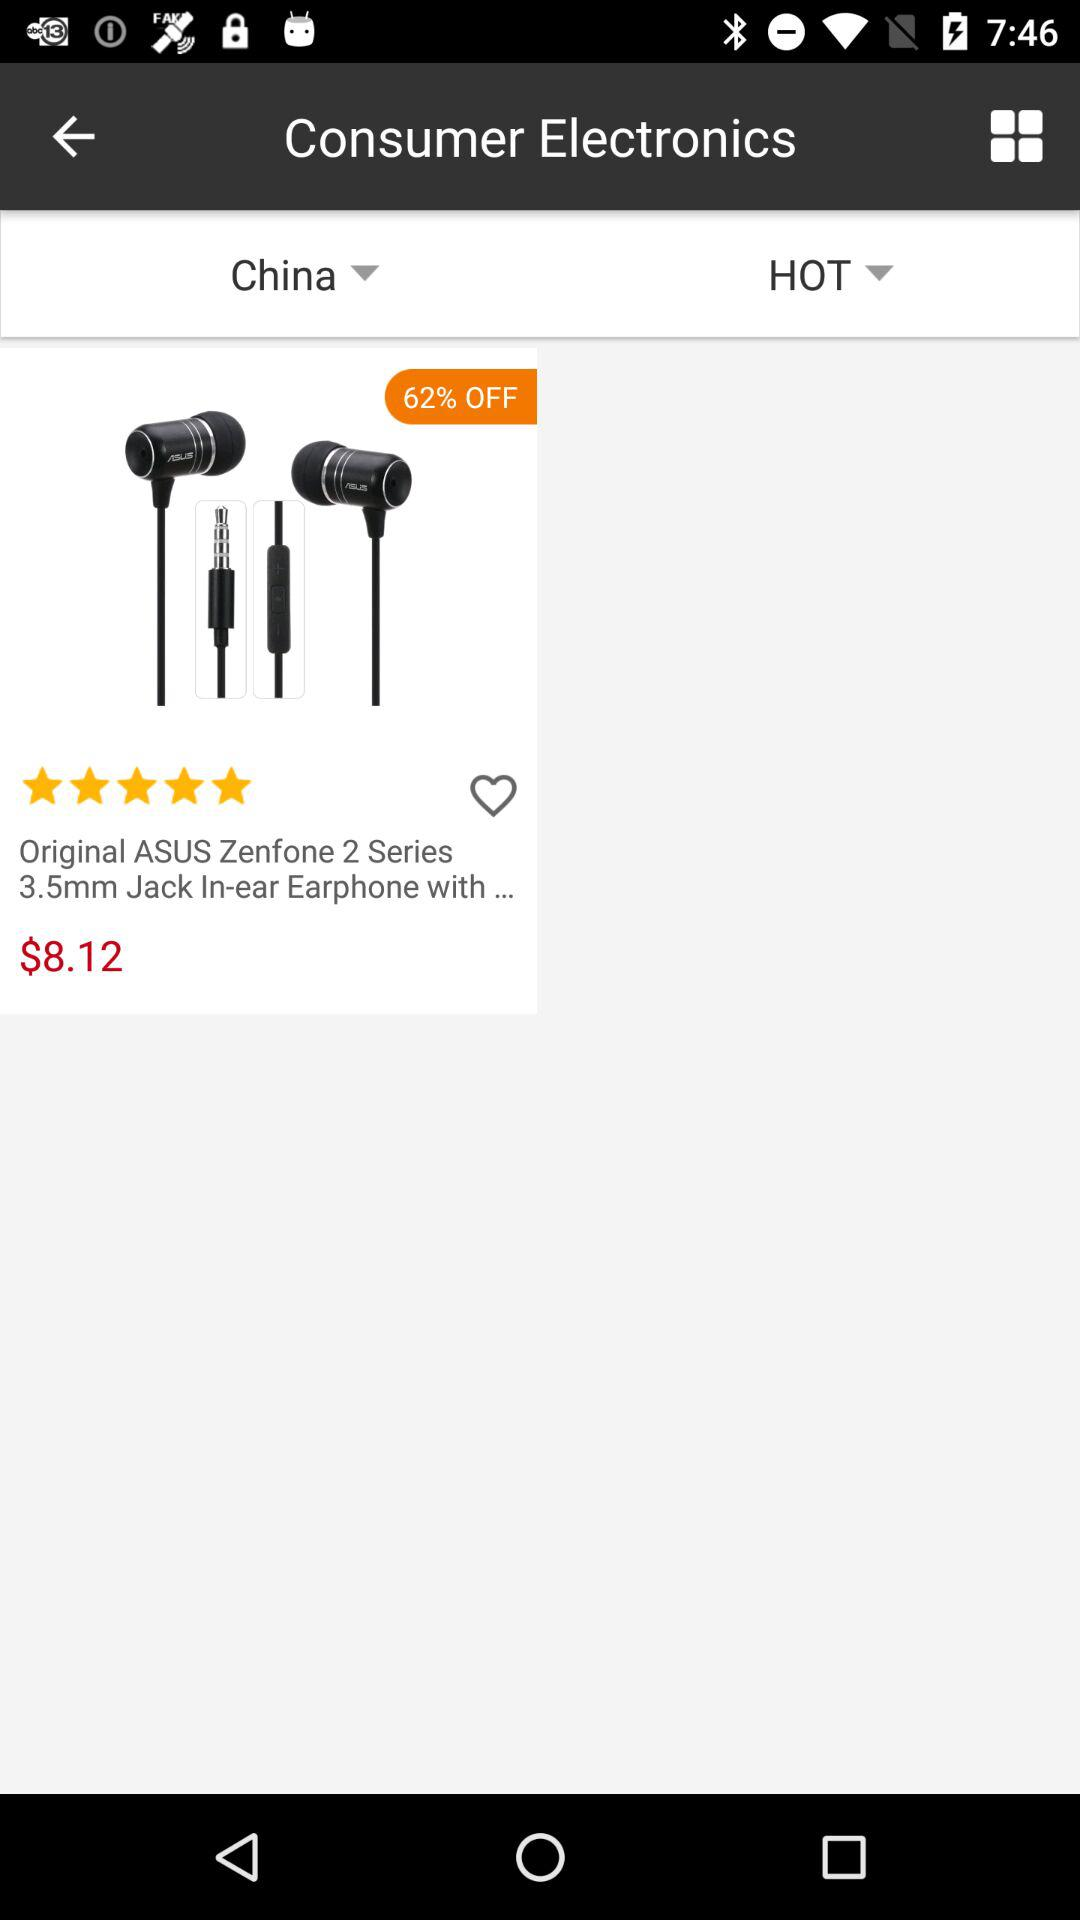What is the price of the earphones? The price of the earphones is $8.12. 